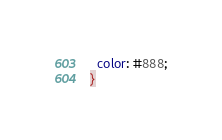<code> <loc_0><loc_0><loc_500><loc_500><_CSS_>  color: #888;
}</code> 